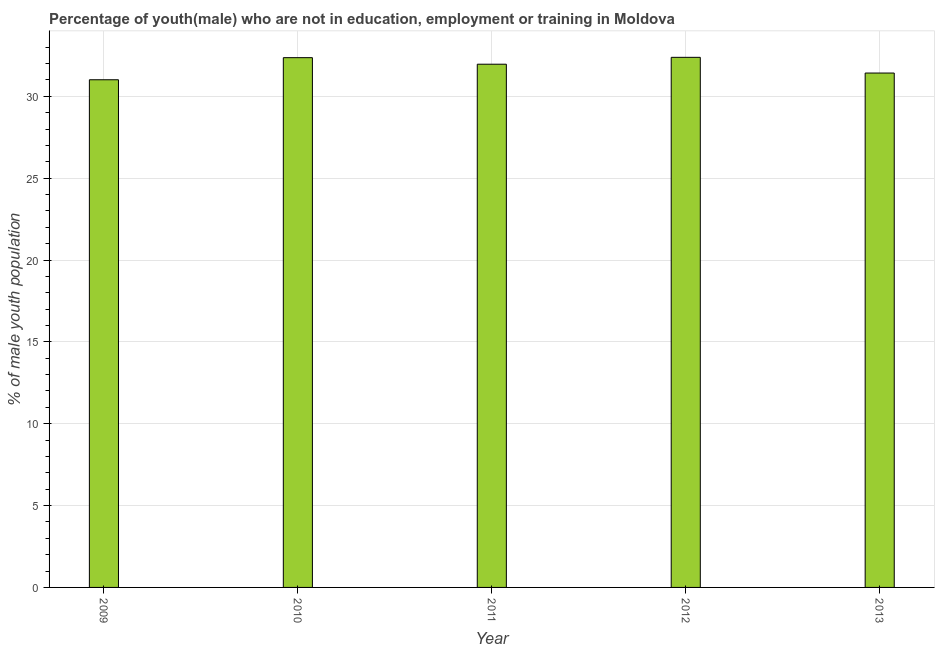What is the title of the graph?
Ensure brevity in your answer.  Percentage of youth(male) who are not in education, employment or training in Moldova. What is the label or title of the Y-axis?
Offer a terse response. % of male youth population. What is the unemployed male youth population in 2010?
Your answer should be compact. 32.36. Across all years, what is the maximum unemployed male youth population?
Offer a very short reply. 32.38. Across all years, what is the minimum unemployed male youth population?
Give a very brief answer. 31.01. What is the sum of the unemployed male youth population?
Give a very brief answer. 159.13. What is the difference between the unemployed male youth population in 2011 and 2012?
Make the answer very short. -0.42. What is the average unemployed male youth population per year?
Your answer should be very brief. 31.83. What is the median unemployed male youth population?
Offer a terse response. 31.96. Do a majority of the years between 2011 and 2010 (inclusive) have unemployed male youth population greater than 32 %?
Your answer should be very brief. No. What is the difference between the highest and the second highest unemployed male youth population?
Give a very brief answer. 0.02. Is the sum of the unemployed male youth population in 2009 and 2010 greater than the maximum unemployed male youth population across all years?
Provide a succinct answer. Yes. What is the difference between the highest and the lowest unemployed male youth population?
Make the answer very short. 1.37. What is the difference between two consecutive major ticks on the Y-axis?
Keep it short and to the point. 5. Are the values on the major ticks of Y-axis written in scientific E-notation?
Your answer should be compact. No. What is the % of male youth population of 2009?
Keep it short and to the point. 31.01. What is the % of male youth population of 2010?
Ensure brevity in your answer.  32.36. What is the % of male youth population of 2011?
Your answer should be compact. 31.96. What is the % of male youth population of 2012?
Make the answer very short. 32.38. What is the % of male youth population of 2013?
Your response must be concise. 31.42. What is the difference between the % of male youth population in 2009 and 2010?
Provide a succinct answer. -1.35. What is the difference between the % of male youth population in 2009 and 2011?
Your answer should be very brief. -0.95. What is the difference between the % of male youth population in 2009 and 2012?
Your answer should be compact. -1.37. What is the difference between the % of male youth population in 2009 and 2013?
Offer a terse response. -0.41. What is the difference between the % of male youth population in 2010 and 2011?
Make the answer very short. 0.4. What is the difference between the % of male youth population in 2010 and 2012?
Make the answer very short. -0.02. What is the difference between the % of male youth population in 2010 and 2013?
Offer a very short reply. 0.94. What is the difference between the % of male youth population in 2011 and 2012?
Give a very brief answer. -0.42. What is the difference between the % of male youth population in 2011 and 2013?
Offer a very short reply. 0.54. What is the ratio of the % of male youth population in 2009 to that in 2010?
Your response must be concise. 0.96. What is the ratio of the % of male youth population in 2009 to that in 2011?
Give a very brief answer. 0.97. What is the ratio of the % of male youth population in 2009 to that in 2012?
Your answer should be very brief. 0.96. What is the ratio of the % of male youth population in 2010 to that in 2012?
Keep it short and to the point. 1. What is the ratio of the % of male youth population in 2011 to that in 2012?
Your answer should be very brief. 0.99. What is the ratio of the % of male youth population in 2012 to that in 2013?
Make the answer very short. 1.03. 